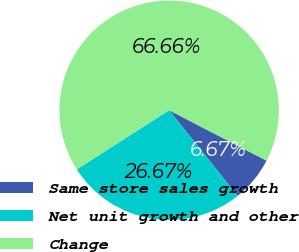<chart> <loc_0><loc_0><loc_500><loc_500><pie_chart><fcel>Same store sales growth<fcel>Net unit growth and other<fcel>Change<nl><fcel>6.67%<fcel>26.67%<fcel>66.67%<nl></chart> 